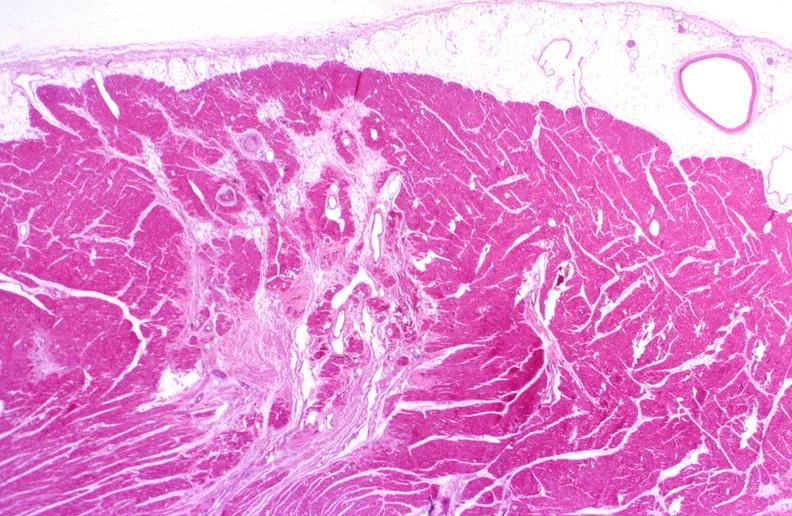what is present?
Answer the question using a single word or phrase. Cardiovascular 